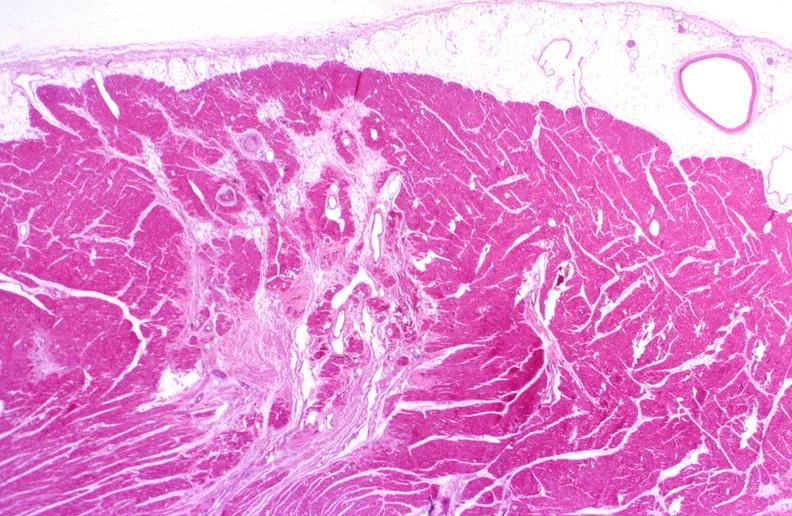what is present?
Answer the question using a single word or phrase. Cardiovascular 